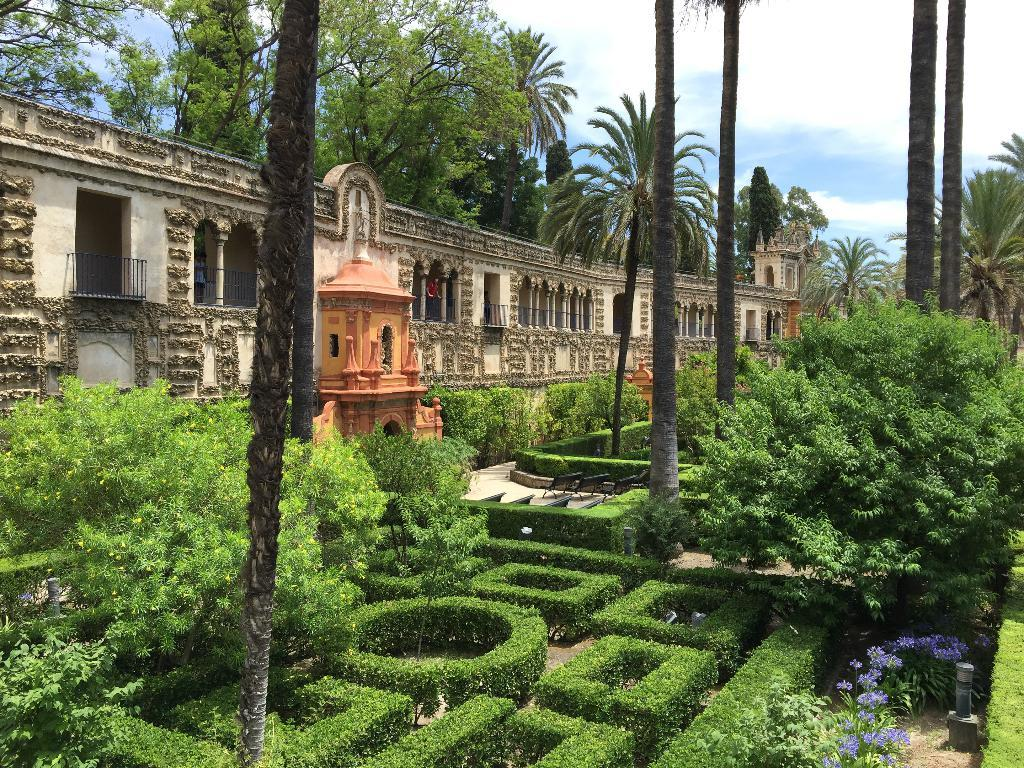What can be seen in the sky in the image? There is a sky in the image, but no specific details are provided about its appearance. What type of vegetation is present in the image? There are trees, flowers, and plants in the image. What type of structure is visible in the image? There is a building in the image. Can you describe the people in the image? There are persons inside the building, but no specific details are provided about their appearance or actions. What type of seating is available in the image? There are benches in the image. How many rings are visible on the persons' fingers in the image? There is no information provided about rings or any jewelry worn by the persons in the image. What type of connection can be seen between the building and the trees in the image? There is no specific connection between the building and the trees in the image; they are simply separate elements in the scene. 